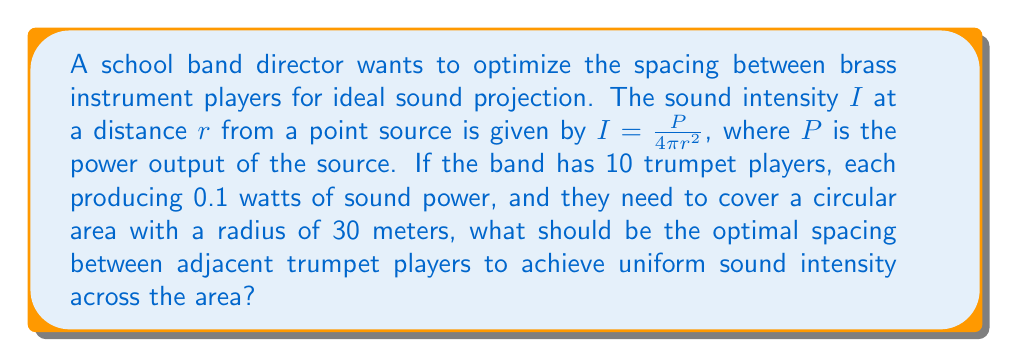What is the answer to this math problem? 1) First, we need to determine the total power output:
   $P_{total} = 10 \times 0.1 \text{ W} = 1 \text{ W}$

2) We want to distribute this power uniformly across the circular area. The area of the circle is:
   $A = \pi r^2 = \pi (30\text{ m})^2 = 2827.43 \text{ m}^2$

3) The uniform intensity across this area would be:
   $I = \frac{P_{total}}{A} = \frac{1 \text{ W}}{2827.43 \text{ m}^2} = 3.54 \times 10^{-4} \text{ W/m}^2$

4) Now, we need to find the distance $r$ at which each trumpet (0.1 W) produces this intensity:
   $3.54 \times 10^{-4} = \frac{0.1}{4\pi r^2}$

5) Solving for $r$:
   $r^2 = \frac{0.1}{4\pi(3.54 \times 10^{-4})} = 22.41 \text{ m}^2$
   $r = 4.73 \text{ m}$

6) To cover the entire circular area uniformly, the trumpets should be arranged in a circle. The circumference of this circle would be:
   $C = 2\pi R = 2\pi(30) = 188.50 \text{ m}$

7) The spacing between adjacent trumpet players would be:
   $\text{Spacing} = \frac{C}{10} = \frac{188.50}{10} = 18.85 \text{ m}$

This spacing ensures that each trumpet contributes equally to the overall sound intensity across the area.
Answer: 18.85 meters 